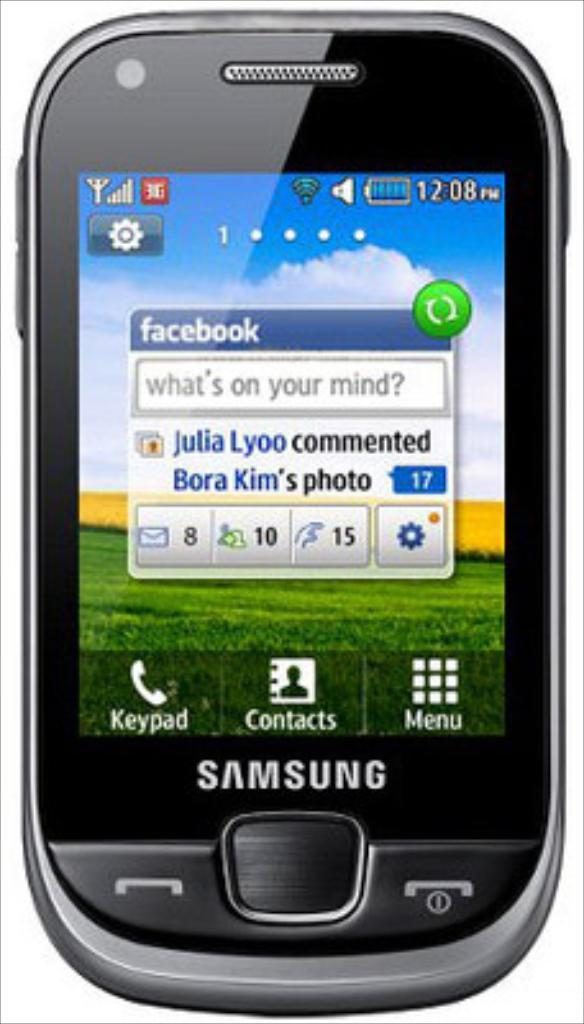<image>
Offer a succinct explanation of the picture presented. A black Samsung phone is against a white backdrop. 